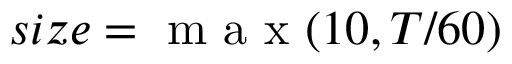Convert formula to latex. <formula><loc_0><loc_0><loc_500><loc_500>s i z e = m a x ( 1 0 , T / 6 0 )</formula> 